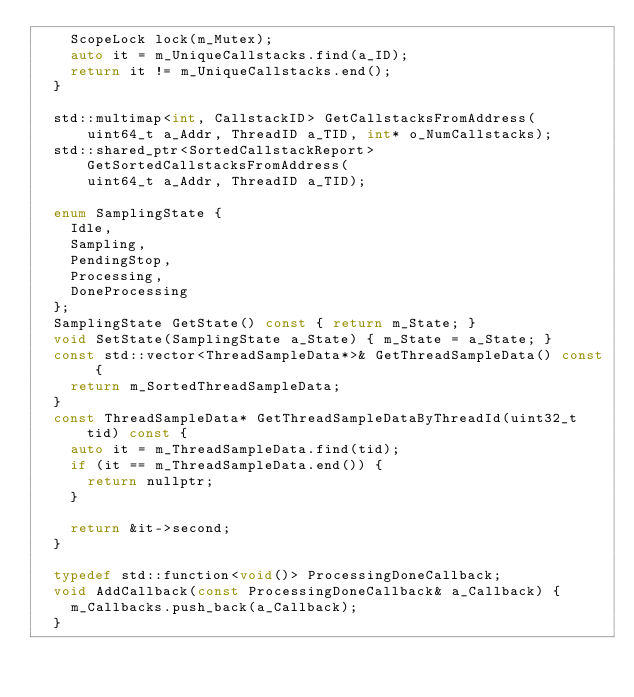<code> <loc_0><loc_0><loc_500><loc_500><_C_>    ScopeLock lock(m_Mutex);
    auto it = m_UniqueCallstacks.find(a_ID);
    return it != m_UniqueCallstacks.end();
  }

  std::multimap<int, CallstackID> GetCallstacksFromAddress(
      uint64_t a_Addr, ThreadID a_TID, int* o_NumCallstacks);
  std::shared_ptr<SortedCallstackReport> GetSortedCallstacksFromAddress(
      uint64_t a_Addr, ThreadID a_TID);

  enum SamplingState {
    Idle,
    Sampling,
    PendingStop,
    Processing,
    DoneProcessing
  };
  SamplingState GetState() const { return m_State; }
  void SetState(SamplingState a_State) { m_State = a_State; }
  const std::vector<ThreadSampleData*>& GetThreadSampleData() const {
    return m_SortedThreadSampleData;
  }
  const ThreadSampleData* GetThreadSampleDataByThreadId(uint32_t tid) const {
    auto it = m_ThreadSampleData.find(tid);
    if (it == m_ThreadSampleData.end()) {
      return nullptr;
    }

    return &it->second;
  }

  typedef std::function<void()> ProcessingDoneCallback;
  void AddCallback(const ProcessingDoneCallback& a_Callback) {
    m_Callbacks.push_back(a_Callback);
  }</code> 